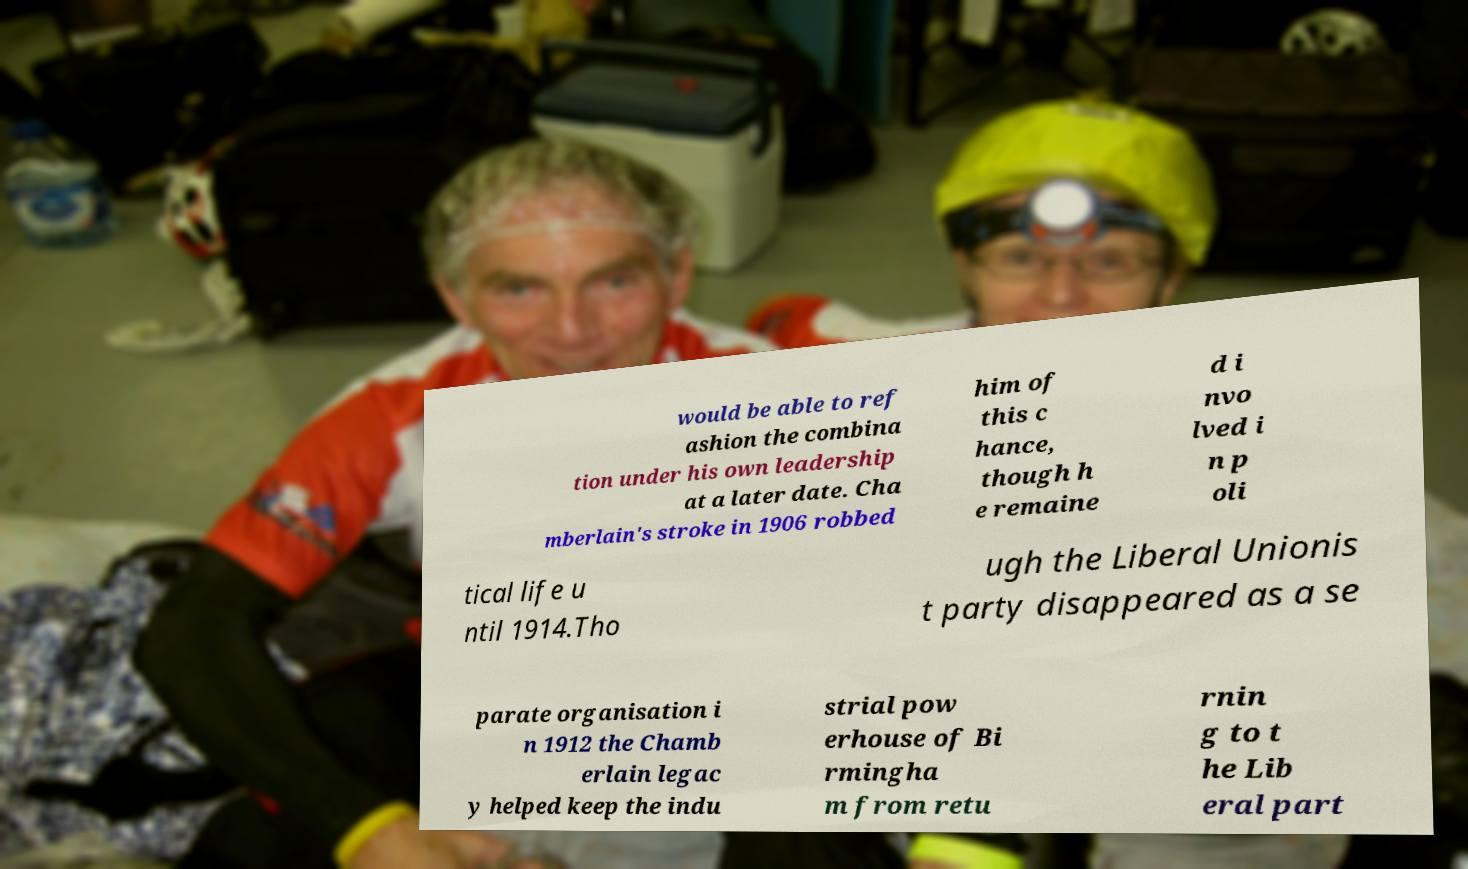Please identify and transcribe the text found in this image. would be able to ref ashion the combina tion under his own leadership at a later date. Cha mberlain's stroke in 1906 robbed him of this c hance, though h e remaine d i nvo lved i n p oli tical life u ntil 1914.Tho ugh the Liberal Unionis t party disappeared as a se parate organisation i n 1912 the Chamb erlain legac y helped keep the indu strial pow erhouse of Bi rmingha m from retu rnin g to t he Lib eral part 